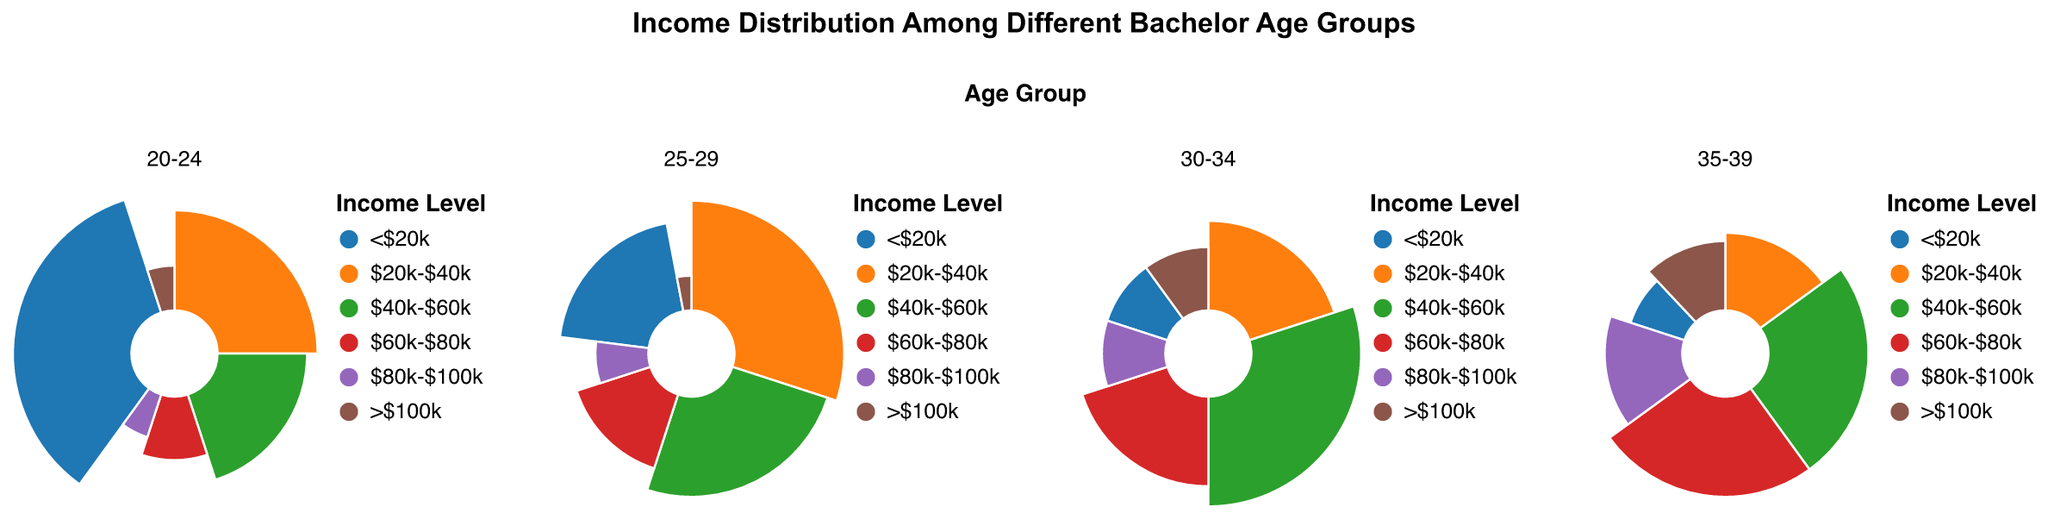What is the age group with the highest percentage of individuals earning less than $20k? By examining all age groups, the 20-24 group shows the largest segment for <$20k (blue) at 35%.
Answer: 20-24 Which income level has the highest percentage within the 30-34 age group? Focus on the 30-34 subplot and identify the largest arc. The green arc representing $40k-$60k occupies 30%.
Answer: $40k-$60k What is the percentage of individuals aged 25-29 earning more than $100k? Look at the 25-29 subplot for the brown segment indicating >$100k. The percentage is 3%.
Answer: 3% How does the percentage of individuals earning $60k-$80k change from the 20-24 to the 35-39 age group? Compare the red arc in each subplot: 10% (20-24), 15% (25-29), 20% (30-34), and 25% (35-39). The percentage increases progressively.
Answer: Increases What is the combined percentage of individuals aged 35-39 earning $60k-$100k? Add the percentages of $60k-$80k and $80k-$100k for 35-39: 25% + 15% = 40%.
Answer: 40% Which age group has the smallest percentage of individuals earning between $80k-$100k? Compare the purple segments across all subplots. The smallest is in the 25-29 age group at 7%.
Answer: 25-29 What is the difference in the percentage of individuals earning less than $20k between age groups 20-24 and 35-39? Look at the blue arcs: 35% (20-24) and 8% (35-39). Calculate the difference: 35% - 8% = 27%.
Answer: 27% Compare the percentage of individuals earning $40k-$60k in the 25-29 and 30-34 age groups. The green arc represents $40k-$60k: 25% (25-29) and 30% (30-34). The 30-34 group has a higher percentage.
Answer: 30-34 Which age group has the most varied distribution of income levels? Examine all subplots for income diversity. The 20-24 group has the widest range from 5% to 35%.
Answer: 20-24 